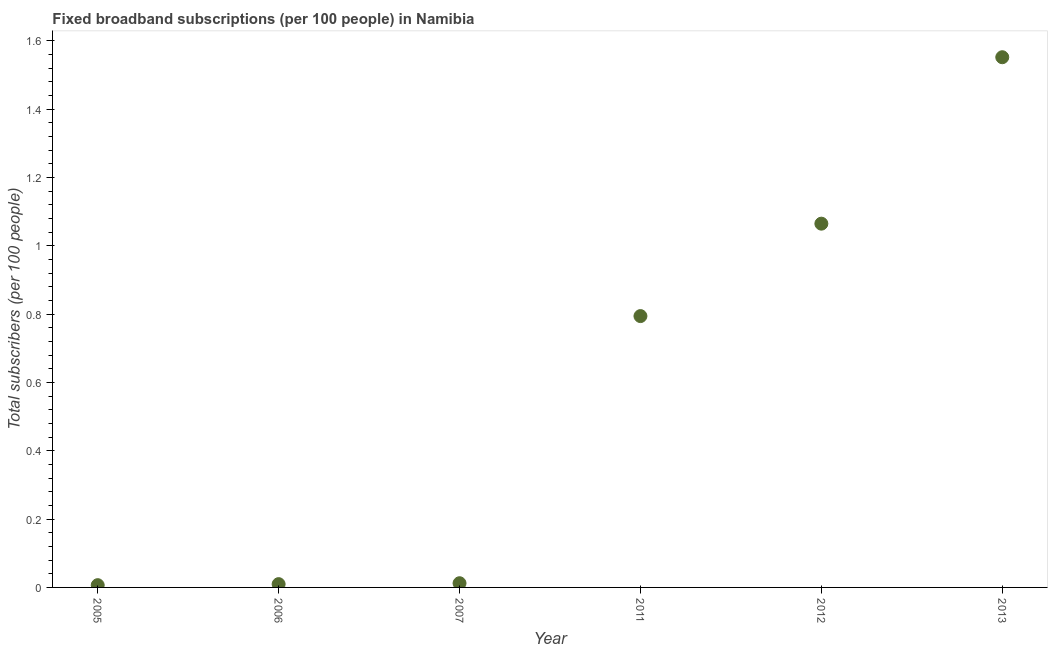What is the total number of fixed broadband subscriptions in 2012?
Keep it short and to the point. 1.06. Across all years, what is the maximum total number of fixed broadband subscriptions?
Provide a succinct answer. 1.55. Across all years, what is the minimum total number of fixed broadband subscriptions?
Offer a very short reply. 0.01. In which year was the total number of fixed broadband subscriptions minimum?
Ensure brevity in your answer.  2005. What is the sum of the total number of fixed broadband subscriptions?
Give a very brief answer. 3.44. What is the difference between the total number of fixed broadband subscriptions in 2007 and 2011?
Offer a terse response. -0.78. What is the average total number of fixed broadband subscriptions per year?
Offer a terse response. 0.57. What is the median total number of fixed broadband subscriptions?
Make the answer very short. 0.4. What is the ratio of the total number of fixed broadband subscriptions in 2005 to that in 2011?
Offer a very short reply. 0.01. Is the total number of fixed broadband subscriptions in 2007 less than that in 2012?
Provide a succinct answer. Yes. What is the difference between the highest and the second highest total number of fixed broadband subscriptions?
Keep it short and to the point. 0.49. What is the difference between the highest and the lowest total number of fixed broadband subscriptions?
Your answer should be compact. 1.55. In how many years, is the total number of fixed broadband subscriptions greater than the average total number of fixed broadband subscriptions taken over all years?
Ensure brevity in your answer.  3. How many years are there in the graph?
Your response must be concise. 6. What is the difference between two consecutive major ticks on the Y-axis?
Your answer should be very brief. 0.2. What is the title of the graph?
Offer a terse response. Fixed broadband subscriptions (per 100 people) in Namibia. What is the label or title of the X-axis?
Offer a very short reply. Year. What is the label or title of the Y-axis?
Offer a terse response. Total subscribers (per 100 people). What is the Total subscribers (per 100 people) in 2005?
Offer a very short reply. 0.01. What is the Total subscribers (per 100 people) in 2006?
Offer a terse response. 0.01. What is the Total subscribers (per 100 people) in 2007?
Offer a terse response. 0.01. What is the Total subscribers (per 100 people) in 2011?
Your answer should be compact. 0.79. What is the Total subscribers (per 100 people) in 2012?
Provide a short and direct response. 1.06. What is the Total subscribers (per 100 people) in 2013?
Provide a succinct answer. 1.55. What is the difference between the Total subscribers (per 100 people) in 2005 and 2006?
Ensure brevity in your answer.  -0. What is the difference between the Total subscribers (per 100 people) in 2005 and 2007?
Give a very brief answer. -0.01. What is the difference between the Total subscribers (per 100 people) in 2005 and 2011?
Provide a succinct answer. -0.79. What is the difference between the Total subscribers (per 100 people) in 2005 and 2012?
Provide a short and direct response. -1.06. What is the difference between the Total subscribers (per 100 people) in 2005 and 2013?
Provide a succinct answer. -1.55. What is the difference between the Total subscribers (per 100 people) in 2006 and 2007?
Your answer should be compact. -0. What is the difference between the Total subscribers (per 100 people) in 2006 and 2011?
Keep it short and to the point. -0.78. What is the difference between the Total subscribers (per 100 people) in 2006 and 2012?
Ensure brevity in your answer.  -1.05. What is the difference between the Total subscribers (per 100 people) in 2006 and 2013?
Your response must be concise. -1.54. What is the difference between the Total subscribers (per 100 people) in 2007 and 2011?
Give a very brief answer. -0.78. What is the difference between the Total subscribers (per 100 people) in 2007 and 2012?
Provide a succinct answer. -1.05. What is the difference between the Total subscribers (per 100 people) in 2007 and 2013?
Keep it short and to the point. -1.54. What is the difference between the Total subscribers (per 100 people) in 2011 and 2012?
Your answer should be very brief. -0.27. What is the difference between the Total subscribers (per 100 people) in 2011 and 2013?
Offer a terse response. -0.76. What is the difference between the Total subscribers (per 100 people) in 2012 and 2013?
Keep it short and to the point. -0.49. What is the ratio of the Total subscribers (per 100 people) in 2005 to that in 2006?
Provide a short and direct response. 0.69. What is the ratio of the Total subscribers (per 100 people) in 2005 to that in 2007?
Ensure brevity in your answer.  0.54. What is the ratio of the Total subscribers (per 100 people) in 2005 to that in 2011?
Your answer should be compact. 0.01. What is the ratio of the Total subscribers (per 100 people) in 2005 to that in 2012?
Keep it short and to the point. 0.01. What is the ratio of the Total subscribers (per 100 people) in 2005 to that in 2013?
Ensure brevity in your answer.  0. What is the ratio of the Total subscribers (per 100 people) in 2006 to that in 2007?
Your response must be concise. 0.78. What is the ratio of the Total subscribers (per 100 people) in 2006 to that in 2011?
Make the answer very short. 0.01. What is the ratio of the Total subscribers (per 100 people) in 2006 to that in 2012?
Offer a very short reply. 0.01. What is the ratio of the Total subscribers (per 100 people) in 2006 to that in 2013?
Offer a very short reply. 0.01. What is the ratio of the Total subscribers (per 100 people) in 2007 to that in 2011?
Your response must be concise. 0.01. What is the ratio of the Total subscribers (per 100 people) in 2007 to that in 2012?
Keep it short and to the point. 0.01. What is the ratio of the Total subscribers (per 100 people) in 2007 to that in 2013?
Your response must be concise. 0.01. What is the ratio of the Total subscribers (per 100 people) in 2011 to that in 2012?
Offer a terse response. 0.75. What is the ratio of the Total subscribers (per 100 people) in 2011 to that in 2013?
Your answer should be very brief. 0.51. What is the ratio of the Total subscribers (per 100 people) in 2012 to that in 2013?
Give a very brief answer. 0.69. 